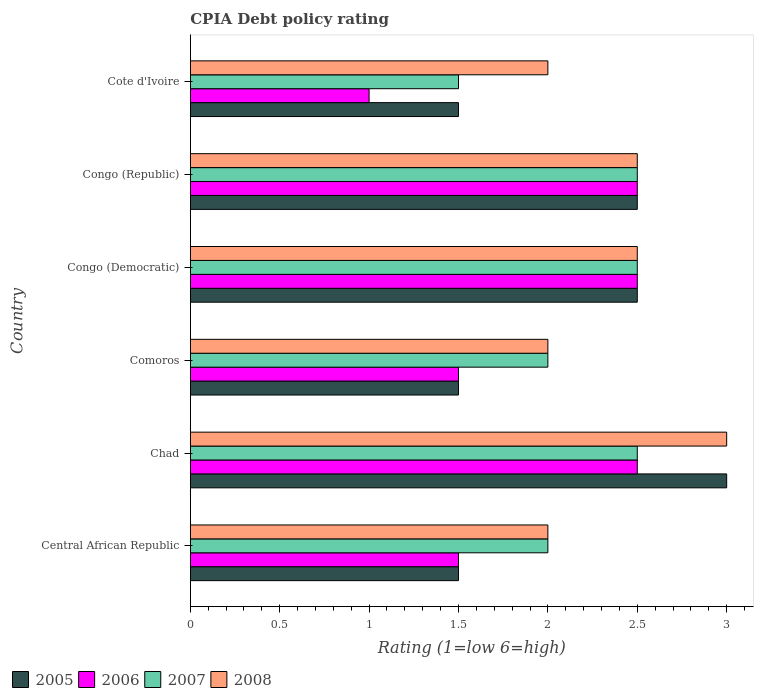How many different coloured bars are there?
Give a very brief answer. 4. Are the number of bars per tick equal to the number of legend labels?
Your answer should be very brief. Yes. Are the number of bars on each tick of the Y-axis equal?
Offer a terse response. Yes. How many bars are there on the 2nd tick from the top?
Make the answer very short. 4. What is the label of the 3rd group of bars from the top?
Your answer should be compact. Congo (Democratic). In which country was the CPIA rating in 2005 maximum?
Provide a short and direct response. Chad. In which country was the CPIA rating in 2005 minimum?
Your answer should be compact. Central African Republic. What is the total CPIA rating in 2005 in the graph?
Your answer should be very brief. 12.5. What is the difference between the CPIA rating in 2007 in Congo (Democratic) and the CPIA rating in 2008 in Comoros?
Offer a very short reply. 0.5. What is the average CPIA rating in 2006 per country?
Your response must be concise. 1.92. In how many countries, is the CPIA rating in 2005 greater than 2.3 ?
Give a very brief answer. 3. What is the ratio of the CPIA rating in 2005 in Central African Republic to that in Cote d'Ivoire?
Make the answer very short. 1. Is the difference between the CPIA rating in 2005 in Central African Republic and Congo (Republic) greater than the difference between the CPIA rating in 2007 in Central African Republic and Congo (Republic)?
Make the answer very short. No. What is the difference between the highest and the lowest CPIA rating in 2007?
Make the answer very short. 1. What does the 1st bar from the bottom in Comoros represents?
Provide a short and direct response. 2005. Is it the case that in every country, the sum of the CPIA rating in 2006 and CPIA rating in 2007 is greater than the CPIA rating in 2008?
Make the answer very short. Yes. How many countries are there in the graph?
Your answer should be very brief. 6. What is the difference between two consecutive major ticks on the X-axis?
Provide a short and direct response. 0.5. Are the values on the major ticks of X-axis written in scientific E-notation?
Your response must be concise. No. Where does the legend appear in the graph?
Offer a terse response. Bottom left. What is the title of the graph?
Offer a very short reply. CPIA Debt policy rating. What is the label or title of the X-axis?
Provide a succinct answer. Rating (1=low 6=high). What is the Rating (1=low 6=high) in 2005 in Central African Republic?
Keep it short and to the point. 1.5. What is the Rating (1=low 6=high) in 2006 in Central African Republic?
Ensure brevity in your answer.  1.5. What is the Rating (1=low 6=high) in 2007 in Central African Republic?
Make the answer very short. 2. What is the Rating (1=low 6=high) of 2008 in Central African Republic?
Offer a terse response. 2. What is the Rating (1=low 6=high) of 2006 in Chad?
Ensure brevity in your answer.  2.5. What is the Rating (1=low 6=high) of 2006 in Comoros?
Your answer should be compact. 1.5. What is the Rating (1=low 6=high) of 2008 in Comoros?
Provide a succinct answer. 2. What is the Rating (1=low 6=high) in 2008 in Congo (Democratic)?
Keep it short and to the point. 2.5. What is the Rating (1=low 6=high) of 2005 in Congo (Republic)?
Your answer should be compact. 2.5. What is the Rating (1=low 6=high) in 2005 in Cote d'Ivoire?
Offer a terse response. 1.5. Across all countries, what is the maximum Rating (1=low 6=high) in 2005?
Offer a terse response. 3. Across all countries, what is the minimum Rating (1=low 6=high) in 2005?
Provide a short and direct response. 1.5. Across all countries, what is the minimum Rating (1=low 6=high) of 2006?
Provide a short and direct response. 1. Across all countries, what is the minimum Rating (1=low 6=high) in 2008?
Give a very brief answer. 2. What is the total Rating (1=low 6=high) of 2008 in the graph?
Make the answer very short. 14. What is the difference between the Rating (1=low 6=high) of 2005 in Central African Republic and that in Chad?
Offer a terse response. -1.5. What is the difference between the Rating (1=low 6=high) of 2006 in Central African Republic and that in Chad?
Ensure brevity in your answer.  -1. What is the difference between the Rating (1=low 6=high) of 2008 in Central African Republic and that in Chad?
Provide a short and direct response. -1. What is the difference between the Rating (1=low 6=high) in 2005 in Central African Republic and that in Comoros?
Offer a very short reply. 0. What is the difference between the Rating (1=low 6=high) in 2006 in Central African Republic and that in Comoros?
Make the answer very short. 0. What is the difference between the Rating (1=low 6=high) of 2007 in Central African Republic and that in Comoros?
Your answer should be very brief. 0. What is the difference between the Rating (1=low 6=high) in 2006 in Central African Republic and that in Congo (Democratic)?
Provide a short and direct response. -1. What is the difference between the Rating (1=low 6=high) of 2008 in Central African Republic and that in Congo (Democratic)?
Make the answer very short. -0.5. What is the difference between the Rating (1=low 6=high) in 2007 in Central African Republic and that in Cote d'Ivoire?
Offer a very short reply. 0.5. What is the difference between the Rating (1=low 6=high) in 2008 in Central African Republic and that in Cote d'Ivoire?
Offer a very short reply. 0. What is the difference between the Rating (1=low 6=high) of 2005 in Chad and that in Comoros?
Keep it short and to the point. 1.5. What is the difference between the Rating (1=low 6=high) of 2007 in Chad and that in Comoros?
Offer a terse response. 0.5. What is the difference between the Rating (1=low 6=high) of 2006 in Chad and that in Congo (Democratic)?
Your answer should be very brief. 0. What is the difference between the Rating (1=low 6=high) of 2006 in Chad and that in Congo (Republic)?
Provide a short and direct response. 0. What is the difference between the Rating (1=low 6=high) in 2007 in Chad and that in Congo (Republic)?
Your response must be concise. 0. What is the difference between the Rating (1=low 6=high) in 2005 in Chad and that in Cote d'Ivoire?
Your answer should be very brief. 1.5. What is the difference between the Rating (1=low 6=high) in 2008 in Chad and that in Cote d'Ivoire?
Your answer should be compact. 1. What is the difference between the Rating (1=low 6=high) of 2005 in Comoros and that in Congo (Democratic)?
Your response must be concise. -1. What is the difference between the Rating (1=low 6=high) in 2006 in Comoros and that in Congo (Republic)?
Keep it short and to the point. -1. What is the difference between the Rating (1=low 6=high) of 2007 in Comoros and that in Congo (Republic)?
Offer a very short reply. -0.5. What is the difference between the Rating (1=low 6=high) of 2006 in Comoros and that in Cote d'Ivoire?
Offer a very short reply. 0.5. What is the difference between the Rating (1=low 6=high) in 2008 in Comoros and that in Cote d'Ivoire?
Provide a short and direct response. 0. What is the difference between the Rating (1=low 6=high) of 2008 in Congo (Democratic) and that in Congo (Republic)?
Keep it short and to the point. 0. What is the difference between the Rating (1=low 6=high) of 2006 in Congo (Democratic) and that in Cote d'Ivoire?
Give a very brief answer. 1.5. What is the difference between the Rating (1=low 6=high) in 2005 in Congo (Republic) and that in Cote d'Ivoire?
Your answer should be compact. 1. What is the difference between the Rating (1=low 6=high) of 2006 in Congo (Republic) and that in Cote d'Ivoire?
Make the answer very short. 1.5. What is the difference between the Rating (1=low 6=high) in 2007 in Congo (Republic) and that in Cote d'Ivoire?
Offer a terse response. 1. What is the difference between the Rating (1=low 6=high) of 2008 in Congo (Republic) and that in Cote d'Ivoire?
Offer a very short reply. 0.5. What is the difference between the Rating (1=low 6=high) of 2005 in Central African Republic and the Rating (1=low 6=high) of 2006 in Chad?
Your answer should be compact. -1. What is the difference between the Rating (1=low 6=high) of 2005 in Central African Republic and the Rating (1=low 6=high) of 2007 in Chad?
Keep it short and to the point. -1. What is the difference between the Rating (1=low 6=high) in 2005 in Central African Republic and the Rating (1=low 6=high) in 2008 in Chad?
Offer a very short reply. -1.5. What is the difference between the Rating (1=low 6=high) in 2006 in Central African Republic and the Rating (1=low 6=high) in 2007 in Chad?
Your answer should be compact. -1. What is the difference between the Rating (1=low 6=high) of 2006 in Central African Republic and the Rating (1=low 6=high) of 2008 in Chad?
Keep it short and to the point. -1.5. What is the difference between the Rating (1=low 6=high) in 2006 in Central African Republic and the Rating (1=low 6=high) in 2008 in Comoros?
Offer a very short reply. -0.5. What is the difference between the Rating (1=low 6=high) in 2007 in Central African Republic and the Rating (1=low 6=high) in 2008 in Comoros?
Provide a succinct answer. 0. What is the difference between the Rating (1=low 6=high) in 2005 in Central African Republic and the Rating (1=low 6=high) in 2007 in Congo (Democratic)?
Offer a terse response. -1. What is the difference between the Rating (1=low 6=high) in 2006 in Central African Republic and the Rating (1=low 6=high) in 2007 in Congo (Democratic)?
Provide a succinct answer. -1. What is the difference between the Rating (1=low 6=high) of 2006 in Central African Republic and the Rating (1=low 6=high) of 2008 in Congo (Democratic)?
Ensure brevity in your answer.  -1. What is the difference between the Rating (1=low 6=high) in 2005 in Central African Republic and the Rating (1=low 6=high) in 2007 in Congo (Republic)?
Offer a terse response. -1. What is the difference between the Rating (1=low 6=high) in 2005 in Central African Republic and the Rating (1=low 6=high) in 2008 in Congo (Republic)?
Your answer should be compact. -1. What is the difference between the Rating (1=low 6=high) in 2006 in Central African Republic and the Rating (1=low 6=high) in 2007 in Congo (Republic)?
Make the answer very short. -1. What is the difference between the Rating (1=low 6=high) in 2006 in Central African Republic and the Rating (1=low 6=high) in 2008 in Congo (Republic)?
Make the answer very short. -1. What is the difference between the Rating (1=low 6=high) of 2007 in Central African Republic and the Rating (1=low 6=high) of 2008 in Congo (Republic)?
Offer a terse response. -0.5. What is the difference between the Rating (1=low 6=high) of 2005 in Central African Republic and the Rating (1=low 6=high) of 2006 in Cote d'Ivoire?
Ensure brevity in your answer.  0.5. What is the difference between the Rating (1=low 6=high) of 2005 in Central African Republic and the Rating (1=low 6=high) of 2007 in Cote d'Ivoire?
Your answer should be compact. 0. What is the difference between the Rating (1=low 6=high) in 2005 in Central African Republic and the Rating (1=low 6=high) in 2008 in Cote d'Ivoire?
Your answer should be very brief. -0.5. What is the difference between the Rating (1=low 6=high) of 2006 in Central African Republic and the Rating (1=low 6=high) of 2007 in Cote d'Ivoire?
Provide a short and direct response. 0. What is the difference between the Rating (1=low 6=high) of 2006 in Central African Republic and the Rating (1=low 6=high) of 2008 in Cote d'Ivoire?
Keep it short and to the point. -0.5. What is the difference between the Rating (1=low 6=high) in 2007 in Central African Republic and the Rating (1=low 6=high) in 2008 in Cote d'Ivoire?
Keep it short and to the point. 0. What is the difference between the Rating (1=low 6=high) of 2005 in Chad and the Rating (1=low 6=high) of 2007 in Comoros?
Ensure brevity in your answer.  1. What is the difference between the Rating (1=low 6=high) in 2005 in Chad and the Rating (1=low 6=high) in 2006 in Congo (Democratic)?
Make the answer very short. 0.5. What is the difference between the Rating (1=low 6=high) of 2005 in Chad and the Rating (1=low 6=high) of 2007 in Congo (Democratic)?
Provide a succinct answer. 0.5. What is the difference between the Rating (1=low 6=high) of 2006 in Chad and the Rating (1=low 6=high) of 2007 in Congo (Democratic)?
Offer a very short reply. 0. What is the difference between the Rating (1=low 6=high) of 2006 in Chad and the Rating (1=low 6=high) of 2008 in Congo (Democratic)?
Your response must be concise. 0. What is the difference between the Rating (1=low 6=high) in 2007 in Chad and the Rating (1=low 6=high) in 2008 in Congo (Democratic)?
Offer a very short reply. 0. What is the difference between the Rating (1=low 6=high) in 2005 in Chad and the Rating (1=low 6=high) in 2007 in Congo (Republic)?
Your response must be concise. 0.5. What is the difference between the Rating (1=low 6=high) of 2005 in Chad and the Rating (1=low 6=high) of 2008 in Congo (Republic)?
Your response must be concise. 0.5. What is the difference between the Rating (1=low 6=high) of 2006 in Chad and the Rating (1=low 6=high) of 2007 in Congo (Republic)?
Keep it short and to the point. 0. What is the difference between the Rating (1=low 6=high) in 2005 in Chad and the Rating (1=low 6=high) in 2006 in Cote d'Ivoire?
Provide a short and direct response. 2. What is the difference between the Rating (1=low 6=high) in 2005 in Chad and the Rating (1=low 6=high) in 2008 in Cote d'Ivoire?
Offer a terse response. 1. What is the difference between the Rating (1=low 6=high) of 2007 in Chad and the Rating (1=low 6=high) of 2008 in Cote d'Ivoire?
Your answer should be compact. 0.5. What is the difference between the Rating (1=low 6=high) of 2005 in Comoros and the Rating (1=low 6=high) of 2006 in Congo (Democratic)?
Ensure brevity in your answer.  -1. What is the difference between the Rating (1=low 6=high) of 2005 in Comoros and the Rating (1=low 6=high) of 2006 in Congo (Republic)?
Offer a terse response. -1. What is the difference between the Rating (1=low 6=high) in 2006 in Comoros and the Rating (1=low 6=high) in 2007 in Congo (Republic)?
Ensure brevity in your answer.  -1. What is the difference between the Rating (1=low 6=high) in 2007 in Comoros and the Rating (1=low 6=high) in 2008 in Congo (Republic)?
Make the answer very short. -0.5. What is the difference between the Rating (1=low 6=high) in 2005 in Comoros and the Rating (1=low 6=high) in 2007 in Cote d'Ivoire?
Make the answer very short. 0. What is the difference between the Rating (1=low 6=high) in 2006 in Comoros and the Rating (1=low 6=high) in 2008 in Cote d'Ivoire?
Your answer should be compact. -0.5. What is the difference between the Rating (1=low 6=high) in 2007 in Comoros and the Rating (1=low 6=high) in 2008 in Cote d'Ivoire?
Make the answer very short. 0. What is the difference between the Rating (1=low 6=high) of 2005 in Congo (Democratic) and the Rating (1=low 6=high) of 2008 in Congo (Republic)?
Provide a succinct answer. 0. What is the difference between the Rating (1=low 6=high) in 2006 in Congo (Democratic) and the Rating (1=low 6=high) in 2007 in Congo (Republic)?
Offer a very short reply. 0. What is the difference between the Rating (1=low 6=high) of 2006 in Congo (Democratic) and the Rating (1=low 6=high) of 2008 in Congo (Republic)?
Your response must be concise. 0. What is the difference between the Rating (1=low 6=high) of 2006 in Congo (Democratic) and the Rating (1=low 6=high) of 2008 in Cote d'Ivoire?
Your response must be concise. 0.5. What is the difference between the Rating (1=low 6=high) in 2007 in Congo (Democratic) and the Rating (1=low 6=high) in 2008 in Cote d'Ivoire?
Provide a short and direct response. 0.5. What is the difference between the Rating (1=low 6=high) of 2005 in Congo (Republic) and the Rating (1=low 6=high) of 2007 in Cote d'Ivoire?
Offer a terse response. 1. What is the difference between the Rating (1=low 6=high) of 2006 in Congo (Republic) and the Rating (1=low 6=high) of 2008 in Cote d'Ivoire?
Provide a succinct answer. 0.5. What is the average Rating (1=low 6=high) in 2005 per country?
Offer a terse response. 2.08. What is the average Rating (1=low 6=high) in 2006 per country?
Your answer should be compact. 1.92. What is the average Rating (1=low 6=high) in 2007 per country?
Give a very brief answer. 2.17. What is the average Rating (1=low 6=high) in 2008 per country?
Provide a short and direct response. 2.33. What is the difference between the Rating (1=low 6=high) of 2005 and Rating (1=low 6=high) of 2007 in Central African Republic?
Your answer should be compact. -0.5. What is the difference between the Rating (1=low 6=high) in 2005 and Rating (1=low 6=high) in 2008 in Central African Republic?
Provide a succinct answer. -0.5. What is the difference between the Rating (1=low 6=high) of 2007 and Rating (1=low 6=high) of 2008 in Central African Republic?
Give a very brief answer. 0. What is the difference between the Rating (1=low 6=high) in 2005 and Rating (1=low 6=high) in 2006 in Chad?
Ensure brevity in your answer.  0.5. What is the difference between the Rating (1=low 6=high) in 2006 and Rating (1=low 6=high) in 2007 in Chad?
Provide a succinct answer. 0. What is the difference between the Rating (1=low 6=high) of 2007 and Rating (1=low 6=high) of 2008 in Chad?
Your response must be concise. -0.5. What is the difference between the Rating (1=low 6=high) of 2005 and Rating (1=low 6=high) of 2006 in Comoros?
Your response must be concise. 0. What is the difference between the Rating (1=low 6=high) of 2005 and Rating (1=low 6=high) of 2007 in Comoros?
Provide a short and direct response. -0.5. What is the difference between the Rating (1=low 6=high) of 2006 and Rating (1=low 6=high) of 2007 in Comoros?
Provide a short and direct response. -0.5. What is the difference between the Rating (1=low 6=high) in 2006 and Rating (1=low 6=high) in 2008 in Comoros?
Provide a succinct answer. -0.5. What is the difference between the Rating (1=low 6=high) of 2007 and Rating (1=low 6=high) of 2008 in Comoros?
Offer a terse response. 0. What is the difference between the Rating (1=low 6=high) in 2005 and Rating (1=low 6=high) in 2006 in Congo (Democratic)?
Give a very brief answer. 0. What is the difference between the Rating (1=low 6=high) in 2005 and Rating (1=low 6=high) in 2007 in Congo (Democratic)?
Your answer should be compact. 0. What is the difference between the Rating (1=low 6=high) in 2005 and Rating (1=low 6=high) in 2008 in Congo (Democratic)?
Provide a succinct answer. 0. What is the difference between the Rating (1=low 6=high) of 2006 and Rating (1=low 6=high) of 2007 in Congo (Democratic)?
Provide a short and direct response. 0. What is the difference between the Rating (1=low 6=high) in 2006 and Rating (1=low 6=high) in 2008 in Congo (Democratic)?
Ensure brevity in your answer.  0. What is the difference between the Rating (1=low 6=high) in 2007 and Rating (1=low 6=high) in 2008 in Congo (Democratic)?
Give a very brief answer. 0. What is the difference between the Rating (1=low 6=high) in 2005 and Rating (1=low 6=high) in 2008 in Congo (Republic)?
Your answer should be compact. 0. What is the difference between the Rating (1=low 6=high) of 2005 and Rating (1=low 6=high) of 2008 in Cote d'Ivoire?
Your answer should be compact. -0.5. What is the difference between the Rating (1=low 6=high) of 2006 and Rating (1=low 6=high) of 2008 in Cote d'Ivoire?
Offer a terse response. -1. What is the ratio of the Rating (1=low 6=high) of 2005 in Central African Republic to that in Chad?
Keep it short and to the point. 0.5. What is the ratio of the Rating (1=low 6=high) in 2008 in Central African Republic to that in Chad?
Ensure brevity in your answer.  0.67. What is the ratio of the Rating (1=low 6=high) of 2006 in Central African Republic to that in Comoros?
Offer a terse response. 1. What is the ratio of the Rating (1=low 6=high) of 2007 in Central African Republic to that in Comoros?
Offer a very short reply. 1. What is the ratio of the Rating (1=low 6=high) in 2008 in Central African Republic to that in Comoros?
Provide a short and direct response. 1. What is the ratio of the Rating (1=low 6=high) of 2006 in Central African Republic to that in Congo (Republic)?
Make the answer very short. 0.6. What is the ratio of the Rating (1=low 6=high) of 2005 in Central African Republic to that in Cote d'Ivoire?
Keep it short and to the point. 1. What is the ratio of the Rating (1=low 6=high) of 2007 in Central African Republic to that in Cote d'Ivoire?
Make the answer very short. 1.33. What is the ratio of the Rating (1=low 6=high) in 2005 in Chad to that in Comoros?
Your answer should be very brief. 2. What is the ratio of the Rating (1=low 6=high) in 2007 in Chad to that in Comoros?
Provide a succinct answer. 1.25. What is the ratio of the Rating (1=low 6=high) of 2008 in Chad to that in Comoros?
Provide a short and direct response. 1.5. What is the ratio of the Rating (1=low 6=high) in 2006 in Chad to that in Congo (Democratic)?
Ensure brevity in your answer.  1. What is the ratio of the Rating (1=low 6=high) in 2008 in Chad to that in Congo (Democratic)?
Your response must be concise. 1.2. What is the ratio of the Rating (1=low 6=high) of 2005 in Chad to that in Congo (Republic)?
Offer a very short reply. 1.2. What is the ratio of the Rating (1=low 6=high) in 2006 in Chad to that in Congo (Republic)?
Your response must be concise. 1. What is the ratio of the Rating (1=low 6=high) in 2007 in Chad to that in Congo (Republic)?
Your answer should be compact. 1. What is the ratio of the Rating (1=low 6=high) of 2008 in Chad to that in Congo (Republic)?
Your answer should be compact. 1.2. What is the ratio of the Rating (1=low 6=high) in 2005 in Chad to that in Cote d'Ivoire?
Offer a terse response. 2. What is the ratio of the Rating (1=low 6=high) of 2006 in Chad to that in Cote d'Ivoire?
Your response must be concise. 2.5. What is the ratio of the Rating (1=low 6=high) in 2007 in Chad to that in Cote d'Ivoire?
Make the answer very short. 1.67. What is the ratio of the Rating (1=low 6=high) in 2008 in Chad to that in Cote d'Ivoire?
Make the answer very short. 1.5. What is the ratio of the Rating (1=low 6=high) of 2008 in Comoros to that in Congo (Republic)?
Make the answer very short. 0.8. What is the ratio of the Rating (1=low 6=high) in 2006 in Comoros to that in Cote d'Ivoire?
Offer a very short reply. 1.5. What is the ratio of the Rating (1=low 6=high) of 2007 in Comoros to that in Cote d'Ivoire?
Make the answer very short. 1.33. What is the ratio of the Rating (1=low 6=high) of 2005 in Congo (Democratic) to that in Congo (Republic)?
Ensure brevity in your answer.  1. What is the ratio of the Rating (1=low 6=high) of 2007 in Congo (Democratic) to that in Congo (Republic)?
Keep it short and to the point. 1. What is the ratio of the Rating (1=low 6=high) in 2008 in Congo (Democratic) to that in Congo (Republic)?
Ensure brevity in your answer.  1. What is the ratio of the Rating (1=low 6=high) in 2005 in Congo (Democratic) to that in Cote d'Ivoire?
Make the answer very short. 1.67. What is the ratio of the Rating (1=low 6=high) in 2006 in Congo (Democratic) to that in Cote d'Ivoire?
Your answer should be compact. 2.5. What is the ratio of the Rating (1=low 6=high) in 2008 in Congo (Democratic) to that in Cote d'Ivoire?
Provide a succinct answer. 1.25. What is the ratio of the Rating (1=low 6=high) of 2005 in Congo (Republic) to that in Cote d'Ivoire?
Give a very brief answer. 1.67. What is the ratio of the Rating (1=low 6=high) in 2006 in Congo (Republic) to that in Cote d'Ivoire?
Make the answer very short. 2.5. What is the ratio of the Rating (1=low 6=high) in 2007 in Congo (Republic) to that in Cote d'Ivoire?
Offer a very short reply. 1.67. What is the difference between the highest and the lowest Rating (1=low 6=high) in 2005?
Provide a succinct answer. 1.5. What is the difference between the highest and the lowest Rating (1=low 6=high) in 2008?
Your answer should be compact. 1. 